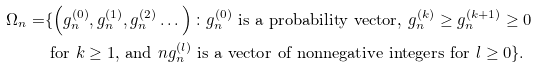<formula> <loc_0><loc_0><loc_500><loc_500>\Omega _ { n } = & \{ \left ( g _ { n } ^ { \left ( 0 \right ) } , g _ { n } ^ { \left ( 1 \right ) } , g _ { n } ^ { \left ( 2 \right ) } \dots \right ) \colon g _ { n } ^ { \left ( 0 \right ) } \text { is a probability vector, } g _ { n } ^ { \left ( k \right ) } \geq g _ { n } ^ { \left ( k + 1 \right ) } \geq 0 \\ & \text { for } k \geq 1 \text {,} \text { and } n g _ { n } ^ { \left ( l \right ) } \text { is a vector of nonnegative integers for } l \geq 0 \} .</formula> 